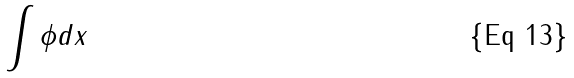Convert formula to latex. <formula><loc_0><loc_0><loc_500><loc_500>\int \phi d x</formula> 